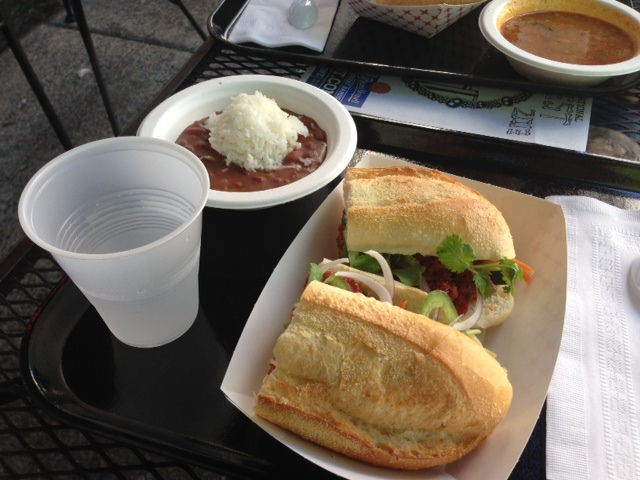Extract all visible text content from this image. ST 2003 T.CO 